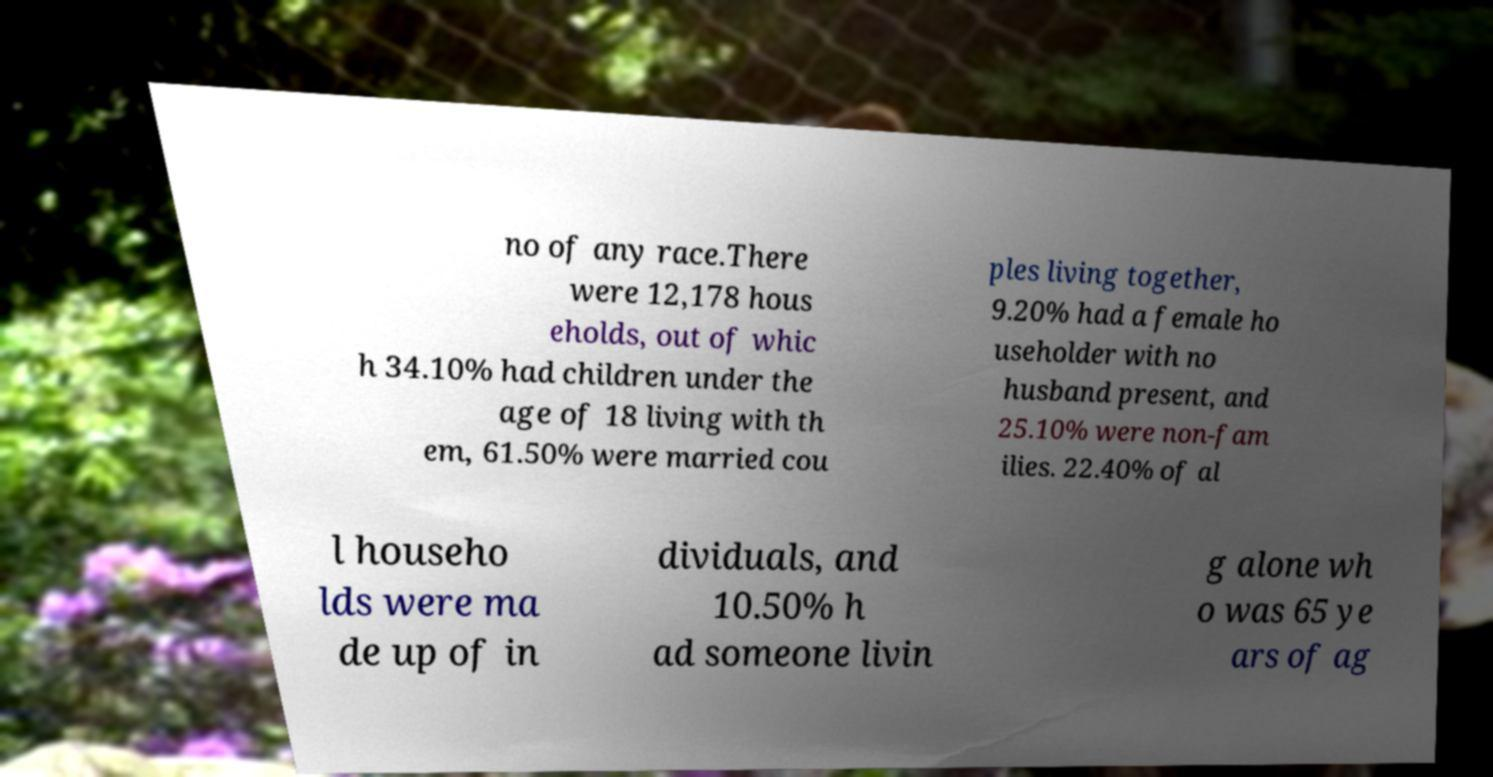For documentation purposes, I need the text within this image transcribed. Could you provide that? no of any race.There were 12,178 hous eholds, out of whic h 34.10% had children under the age of 18 living with th em, 61.50% were married cou ples living together, 9.20% had a female ho useholder with no husband present, and 25.10% were non-fam ilies. 22.40% of al l househo lds were ma de up of in dividuals, and 10.50% h ad someone livin g alone wh o was 65 ye ars of ag 